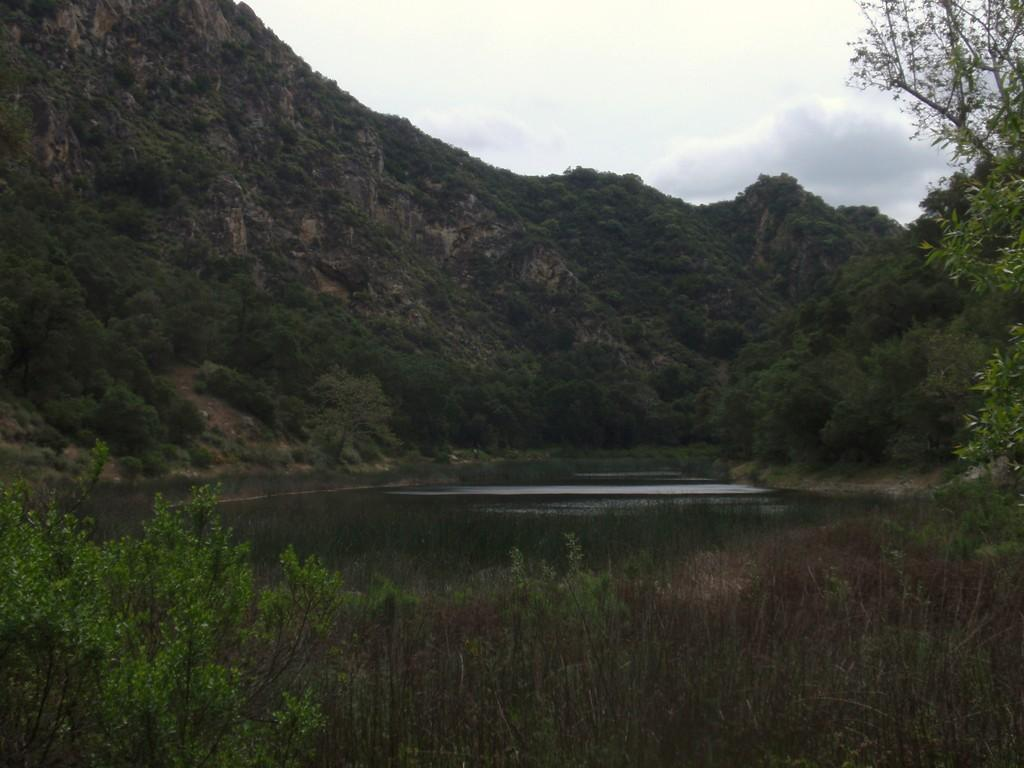What can be seen in the foreground of the image? There is greenery in the foreground of the image. What is located in the middle of the image? There is water in the middle of the image. Where is there more greenery in the image? There is greenery on a cliff in the image. What is visible at the top of the image? The sky is visible at the top of the image. How does the yard appear in the image? There is no yard present in the image; it features greenery, water, and a cliff. What type of rail can be seen in the image? There is no rail present in the image. 